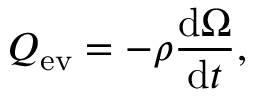Convert formula to latex. <formula><loc_0><loc_0><loc_500><loc_500>Q _ { e v } = - \rho \frac { d \Omega } { d t } ,</formula> 